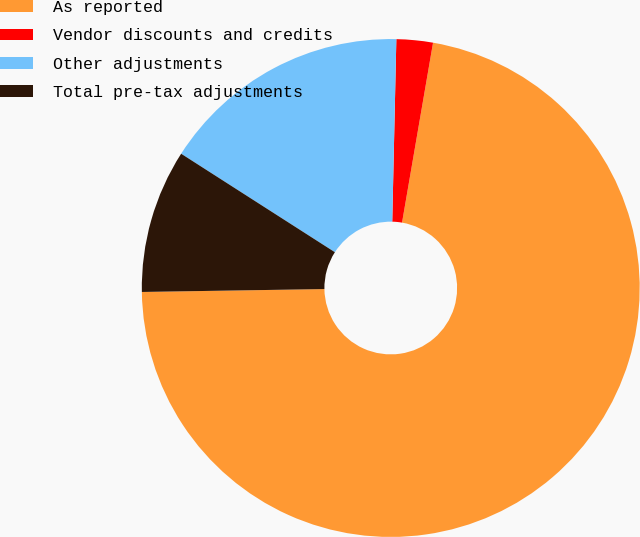Convert chart to OTSL. <chart><loc_0><loc_0><loc_500><loc_500><pie_chart><fcel>As reported<fcel>Vendor discounts and credits<fcel>Other adjustments<fcel>Total pre-tax adjustments<nl><fcel>72.03%<fcel>2.36%<fcel>16.29%<fcel>9.32%<nl></chart> 